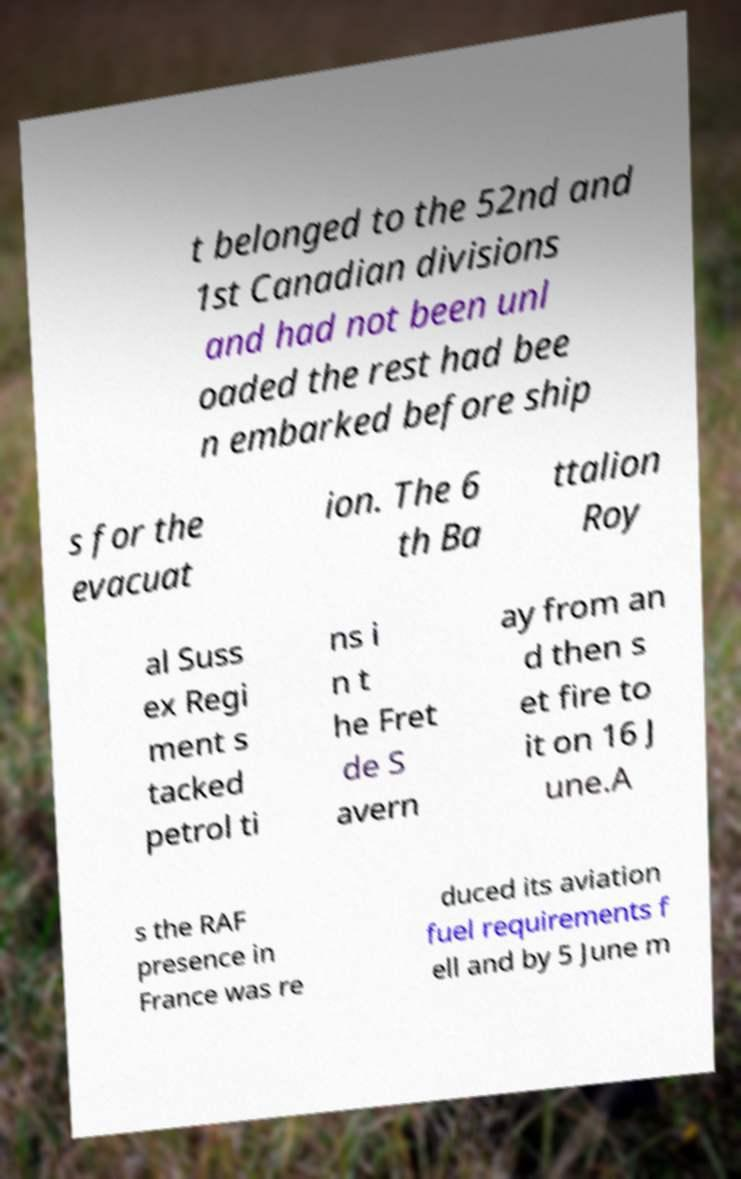Can you read and provide the text displayed in the image?This photo seems to have some interesting text. Can you extract and type it out for me? t belonged to the 52nd and 1st Canadian divisions and had not been unl oaded the rest had bee n embarked before ship s for the evacuat ion. The 6 th Ba ttalion Roy al Suss ex Regi ment s tacked petrol ti ns i n t he Fret de S avern ay from an d then s et fire to it on 16 J une.A s the RAF presence in France was re duced its aviation fuel requirements f ell and by 5 June m 